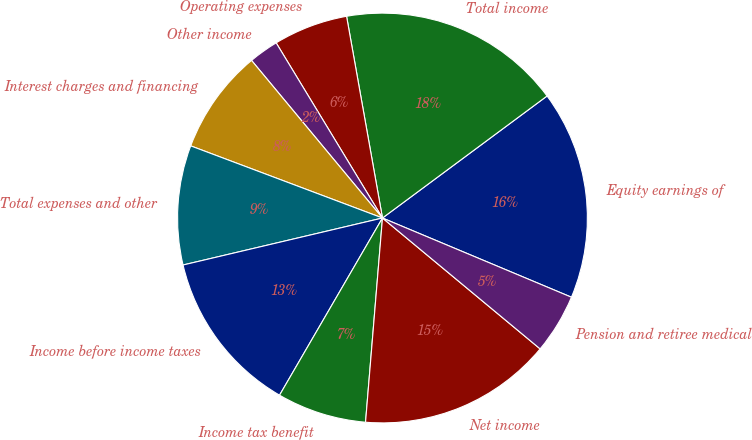Convert chart. <chart><loc_0><loc_0><loc_500><loc_500><pie_chart><fcel>Equity earnings of<fcel>Total income<fcel>Operating expenses<fcel>Other income<fcel>Interest charges and financing<fcel>Total expenses and other<fcel>Income before income taxes<fcel>Income tax benefit<fcel>Net income<fcel>Pension and retiree medical<nl><fcel>16.47%<fcel>17.65%<fcel>5.88%<fcel>2.35%<fcel>8.24%<fcel>9.41%<fcel>12.94%<fcel>7.06%<fcel>15.29%<fcel>4.71%<nl></chart> 